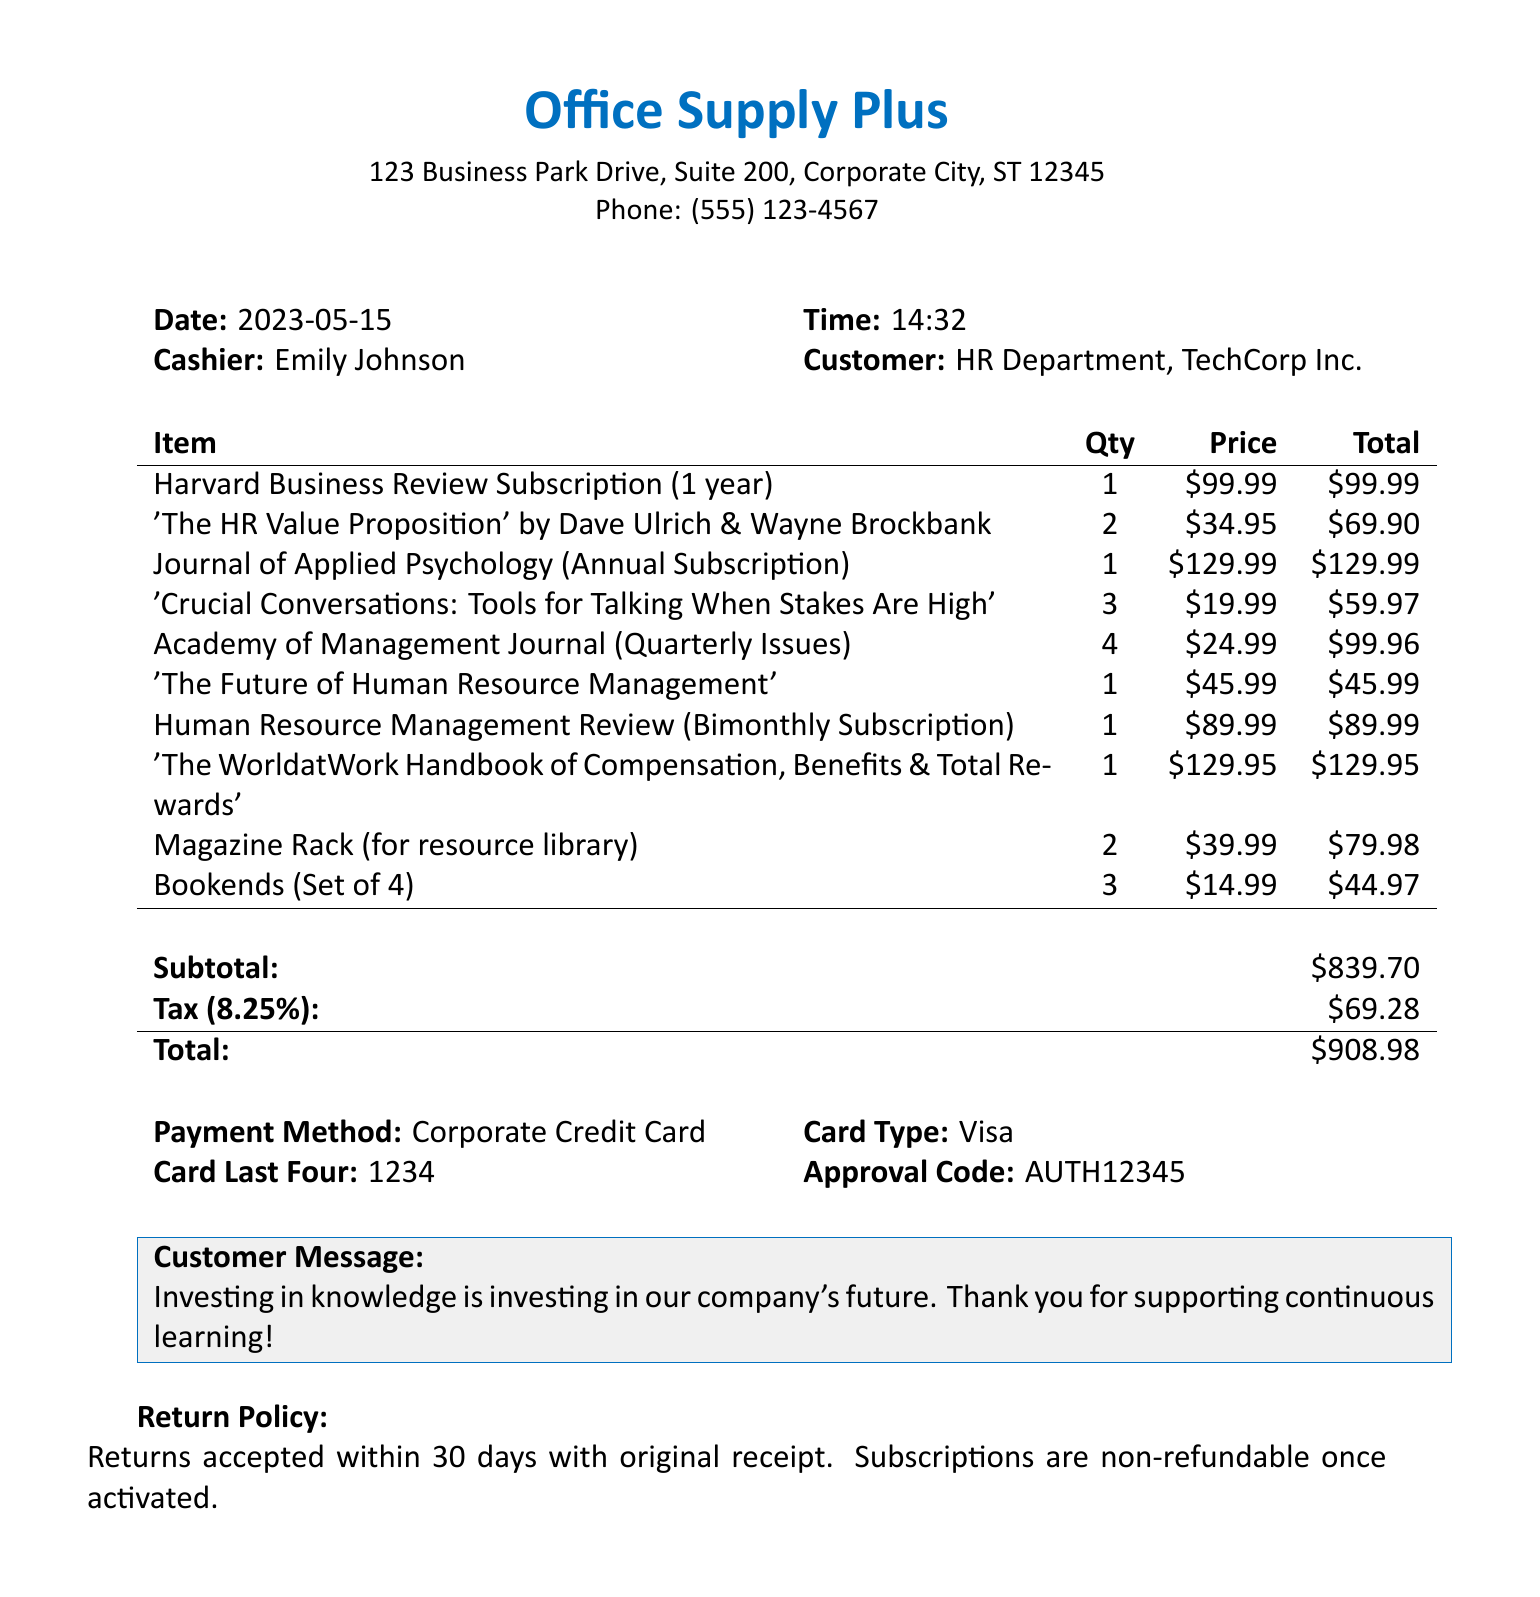what is the store name? The store name is the first item listed in the document's header.
Answer: Office Supply Plus what is the date of purchase? The date of purchase is stated right next to the label "Date:" in the document.
Answer: 2023-05-15 who is the cashier? The cashier's name is mentioned next to the label "Cashier:" in the document.
Answer: Emily Johnson what is the total amount spent? The total amount spent is found under the "Total:" section at the bottom of the receipt.
Answer: $908.98 how many copies of 'The HR Value Proposition' were purchased? The quantity of 'The HR Value Proposition' is specified next to the book title in the item list.
Answer: 2 what is the tax rate applied to the purchase? The tax rate can be found in the tax section of the document right below the subtotal.
Answer: 8.25% how many Magazine Racks were bought? The quantity of Magazine Racks is indicated next to the item in the item list section.
Answer: 2 what is the customer's message? The customer's message is found in a highlighted section of the receipt to emphasize its importance.
Answer: Investing in knowledge is investing in our company's future. Thank you for supporting continuous learning! what is the return policy? The return policy is a statement found at the end of the receipt, detailing conditions for returns.
Answer: Returns accepted within 30 days with original receipt. Subscriptions are non-refundable once activated 